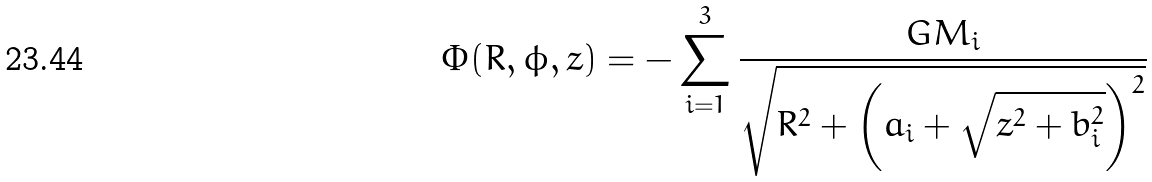Convert formula to latex. <formula><loc_0><loc_0><loc_500><loc_500>\Phi ( R , \phi , z ) = - \sum _ { i = 1 } ^ { 3 } \frac { G M _ { i } } { \sqrt { R ^ { 2 } + \left ( a _ { i } + \sqrt { z ^ { 2 } + b _ { i } ^ { 2 } } \right ) ^ { 2 } } }</formula> 